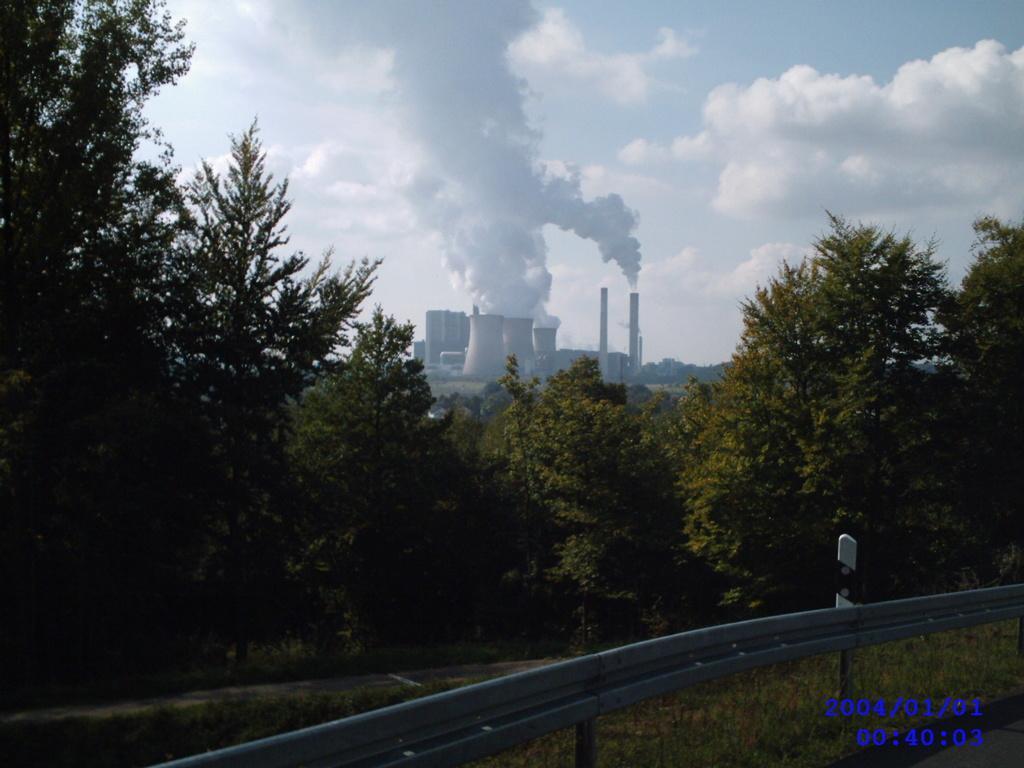In one or two sentences, can you explain what this image depicts? In this image we can see smoke from the chimneys, trees, barriers, grass and sky with clouds. 